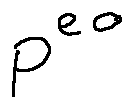<formula> <loc_0><loc_0><loc_500><loc_500>P ^ { e o }</formula> 